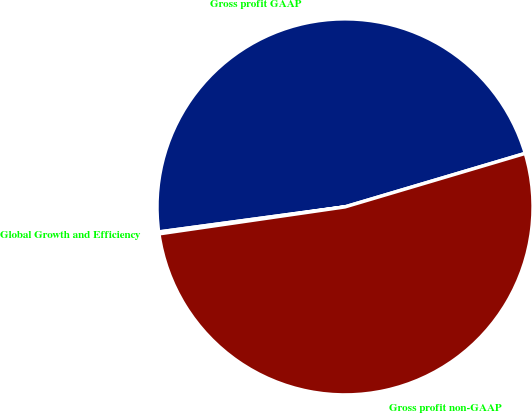<chart> <loc_0><loc_0><loc_500><loc_500><pie_chart><fcel>Gross profit GAAP<fcel>Global Growth and Efficiency<fcel>Gross profit non-GAAP<nl><fcel>47.54%<fcel>0.16%<fcel>52.3%<nl></chart> 